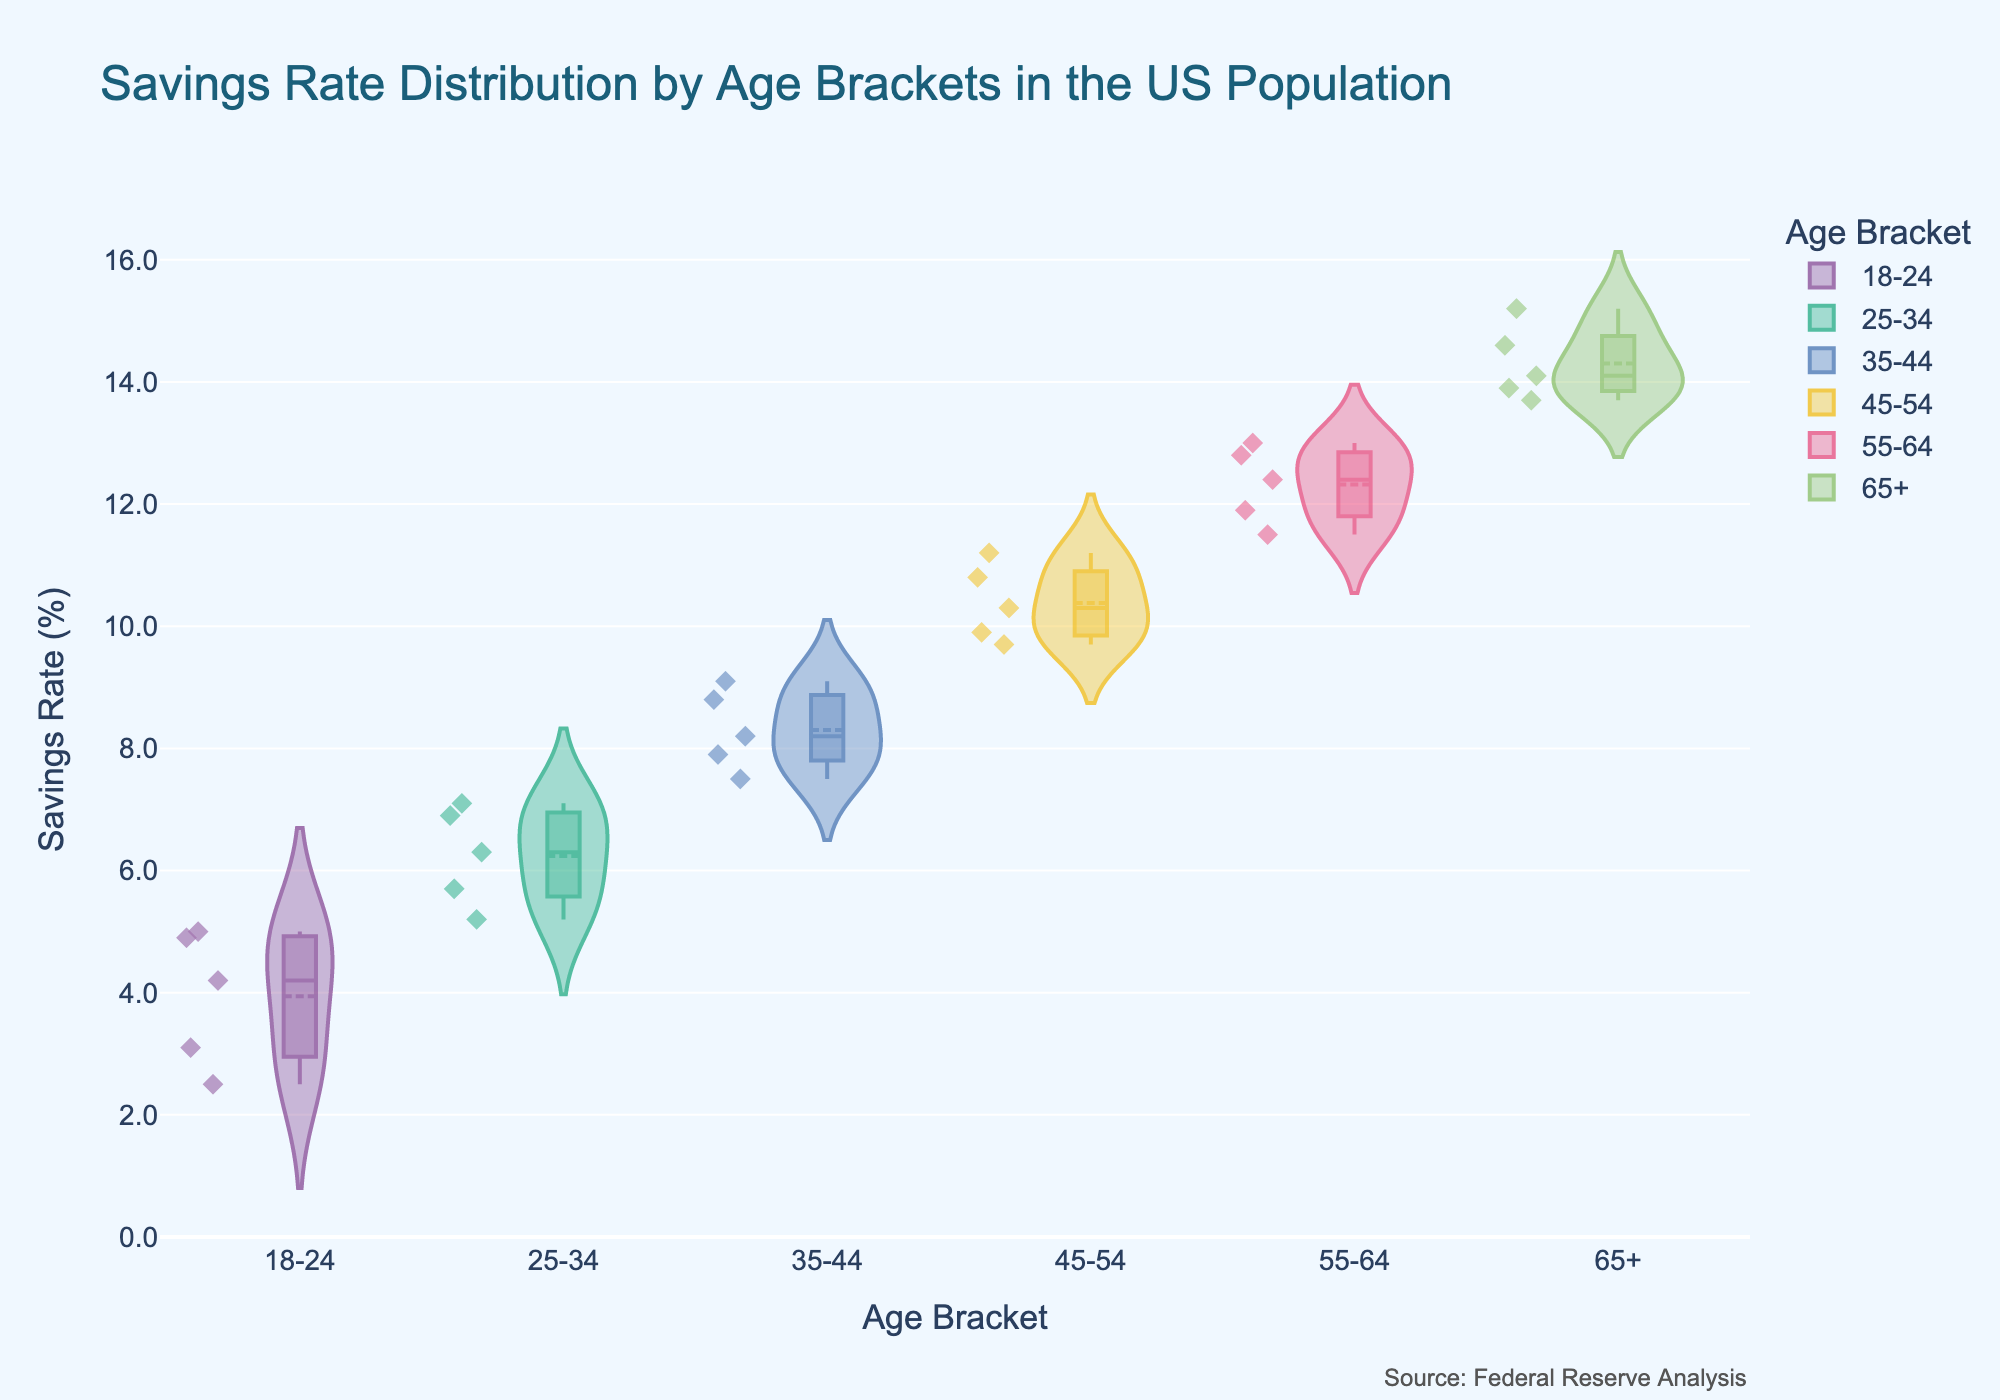What is the title of the chart? The title can be found at the top of the chart where it is clearly labeled. This chart's title is "Savings Rate Distribution by Age Brackets in the US Population".
Answer: Savings Rate Distribution by Age Brackets in the US Population Which age bracket has the highest median savings rate? Violin plots show the median as a line within the box plot inside the violin shape. Looking at the median line, the "65+" age bracket has the highest median savings rate.
Answer: 65+ Are the savings rates more spread out for younger or older age brackets? The width of the violin plot shows the distribution's spread. Observing the violins, the "18-24" bracket is narrower, indicating less spread, while the older brackets, especially "55-64" and "65+", show wider distributions.
Answer: Older age brackets Which age bracket has the lowest range in savings rate? The range is observed from the top of the highest box whisker to the bottom of the lowest whisker within each violin. The "18-24" age bracket has the lowest overall range in savings rate.
Answer: 18-24 What is the interquartile range (IQR) of the savings rate for the "25-34" age bracket? IQR can be calculated from the box in the violin plot. For the "25-34" bracket, the box spans from roughly 5.5% to 6.9%, making the IQR approximately 6.9% - 5.5% = 1.4%.
Answer: 1.4% Which age bracket has the most outliers? Outliers are the points outside the whiskers of the box in the violin plot. By visually counting the dots outside the whiskers, the "65+" bracket appears to have the most outliers.
Answer: 65+ How does the median of the "45-54" age bracket compare to the median of the "35-44" age bracket? Referring to the line in the middle of the boxes, we see that the "45-54" bracket has a higher median compared to the "35-44" bracket.
Answer: 45-54 has a higher median What is the highest individual savings rate observed for any age bracket, and which age bracket does it belong to? By locating the highest point in any of the violin plots, we see that the highest savings rate is in the "65+" bracket, with a rate around 15.2%.
Answer: 15.2% in 65+ Is there any age bracket where the majority of individuals have savings rates above 7%? The majority's stance can be inferred from the thickest part of the violin. For "18-24" and "25-34" age brackets, most of the data is below 7%, while for the other brackets, the majority is above 7%.
Answer: Yes, for age brackets 35-44, 45-54, 55-64, and 65+ Which age bracket shows the most symmetrical distribution of savings rate? Symmetry in the violin plot implies an even distribution of data points on both sides of the median. The "55-64" age bracket appears to have the most symmetrical shape.
Answer: 55-64 